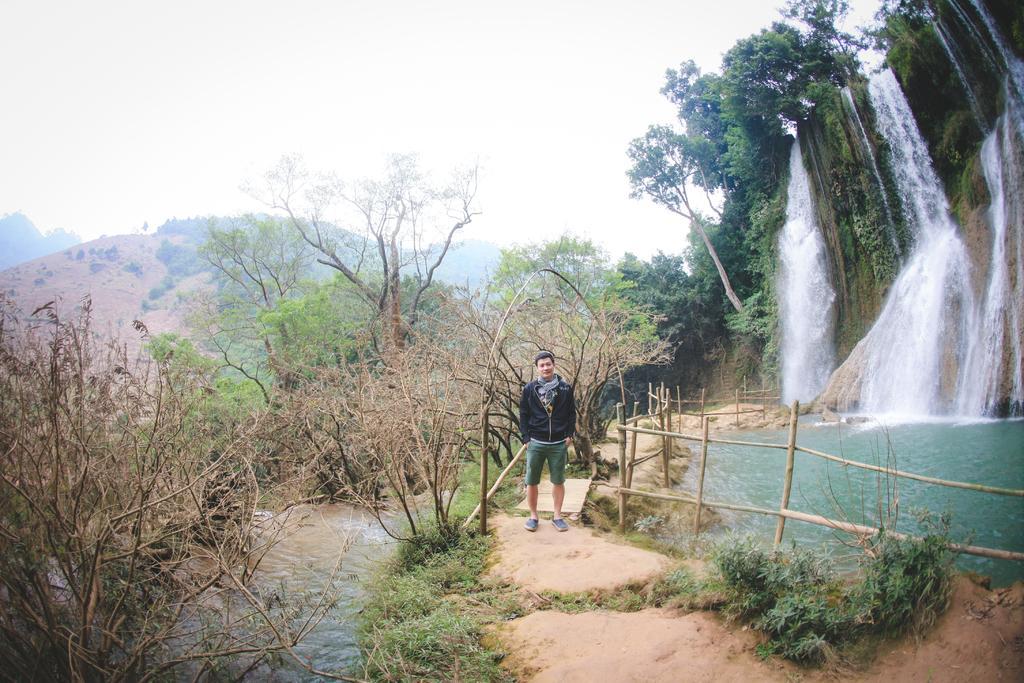In one or two sentences, can you explain what this image depicts? There is a person in black color coat, standing on the ground, near a wooden fencing. On the left side, there is a lake. On both sides of this lake, there are trees and plants. On the right side, there is waterfall and water pond, which is near a path. In the background, there are trees, mountains and there is sky. 